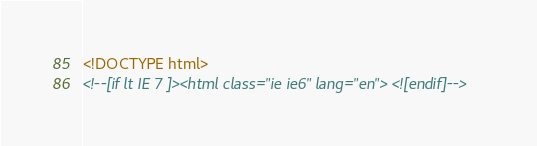Convert code to text. <code><loc_0><loc_0><loc_500><loc_500><_HTML_><!DOCTYPE html>
<!--[if lt IE 7 ]><html class="ie ie6" lang="en"> <![endif]--></code> 